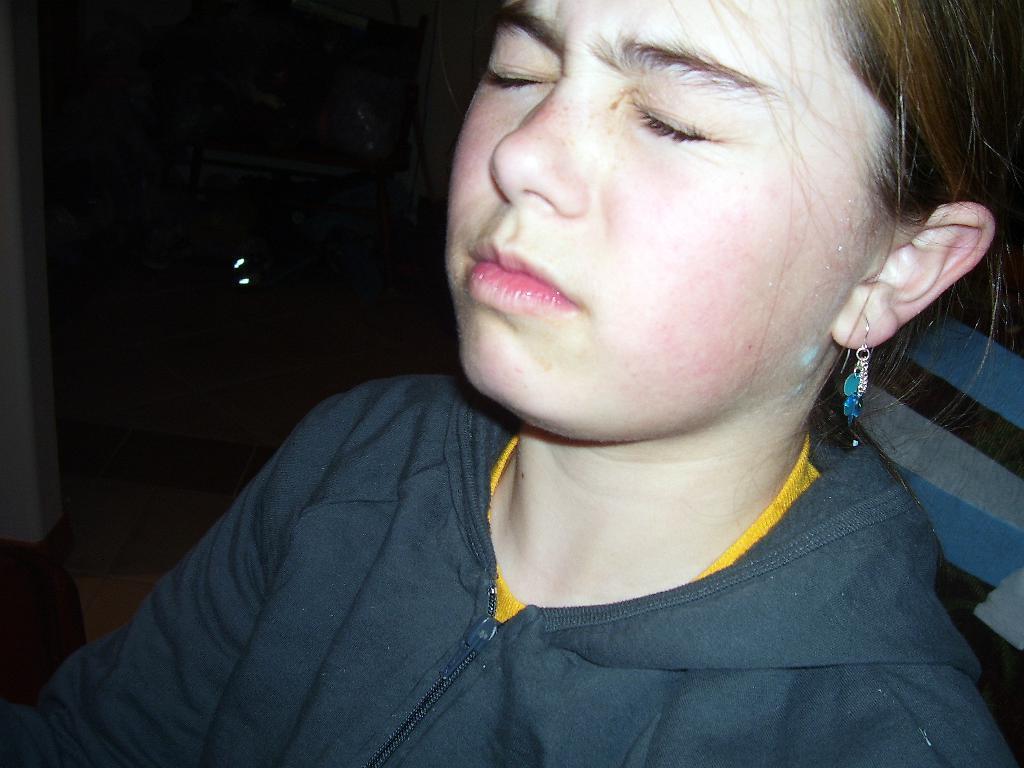In one or two sentences, can you explain what this image depicts? This image consists of a girl wearing a black jacket. On the left, it looks like a wall. The background is too dark. And she is closing her eyes. 